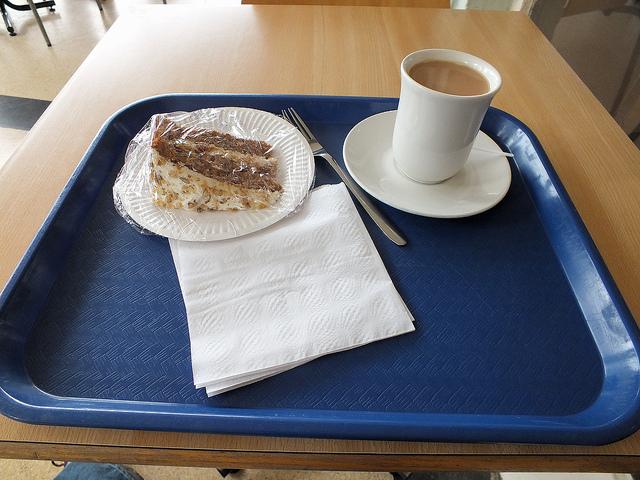How many pieces of silverware is on the tray?
Quick response, please. 1. What is covering the cake?
Quick response, please. Plastic wrap. What color are the napkins?
Short answer required. White. 